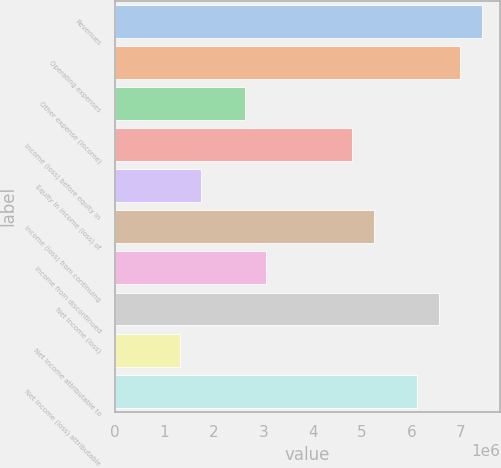Convert chart. <chart><loc_0><loc_0><loc_500><loc_500><bar_chart><fcel>Revenues<fcel>Operating expenses<fcel>Other expense (income)<fcel>Income (loss) before equity in<fcel>Equity in income (loss) of<fcel>Income (loss) from continuing<fcel>Income from discontinued<fcel>Net income (loss)<fcel>Net income attributable to<fcel>Net income (loss) attributable<nl><fcel>7.42422e+06<fcel>6.9875e+06<fcel>2.62032e+06<fcel>4.80391e+06<fcel>1.74688e+06<fcel>5.24063e+06<fcel>3.05703e+06<fcel>6.55079e+06<fcel>1.31016e+06<fcel>6.11407e+06<nl></chart> 